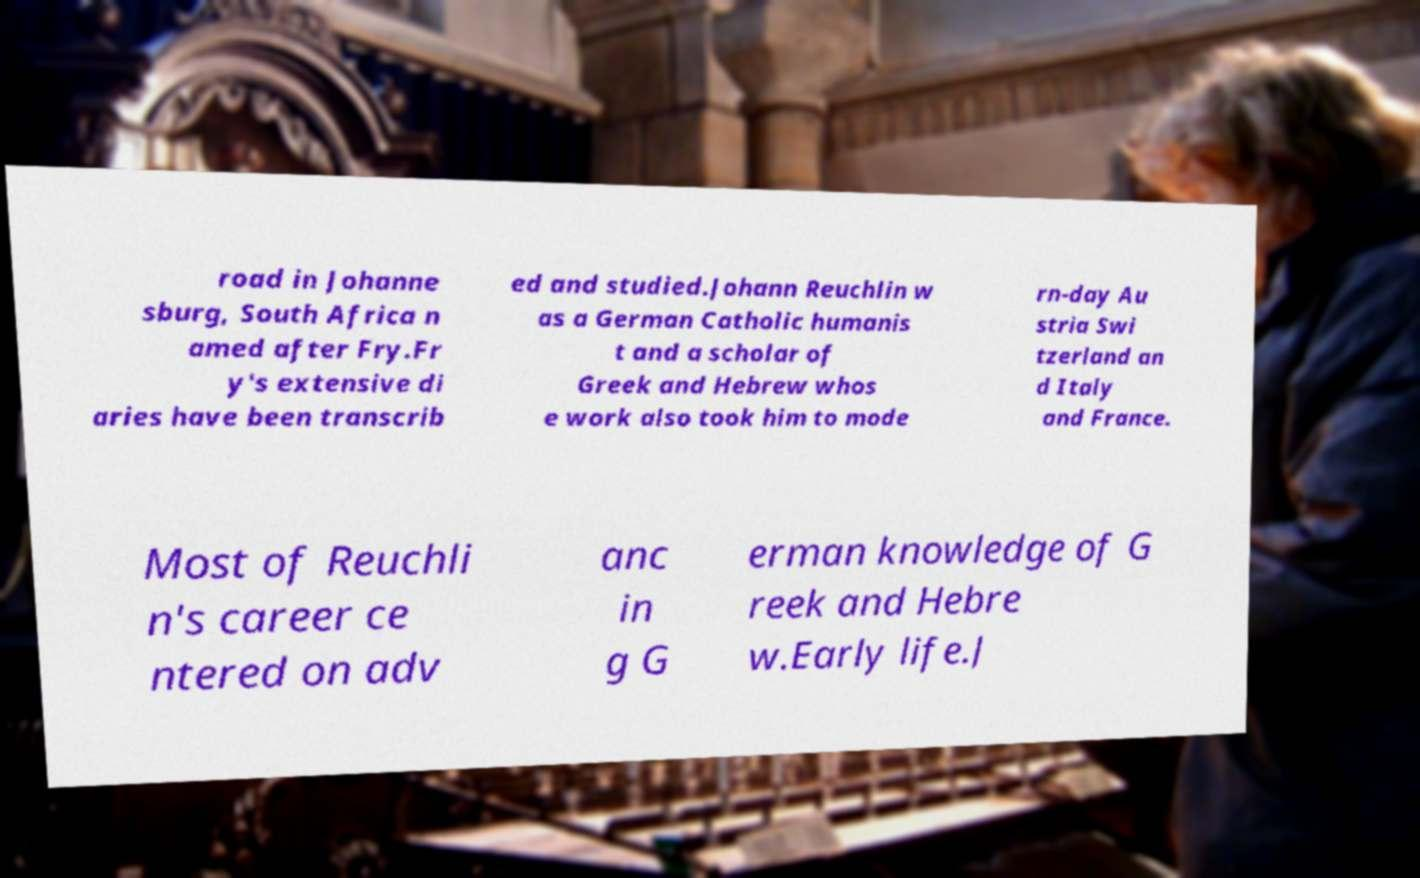There's text embedded in this image that I need extracted. Can you transcribe it verbatim? road in Johanne sburg, South Africa n amed after Fry.Fr y's extensive di aries have been transcrib ed and studied.Johann Reuchlin w as a German Catholic humanis t and a scholar of Greek and Hebrew whos e work also took him to mode rn-day Au stria Swi tzerland an d Italy and France. Most of Reuchli n's career ce ntered on adv anc in g G erman knowledge of G reek and Hebre w.Early life.J 